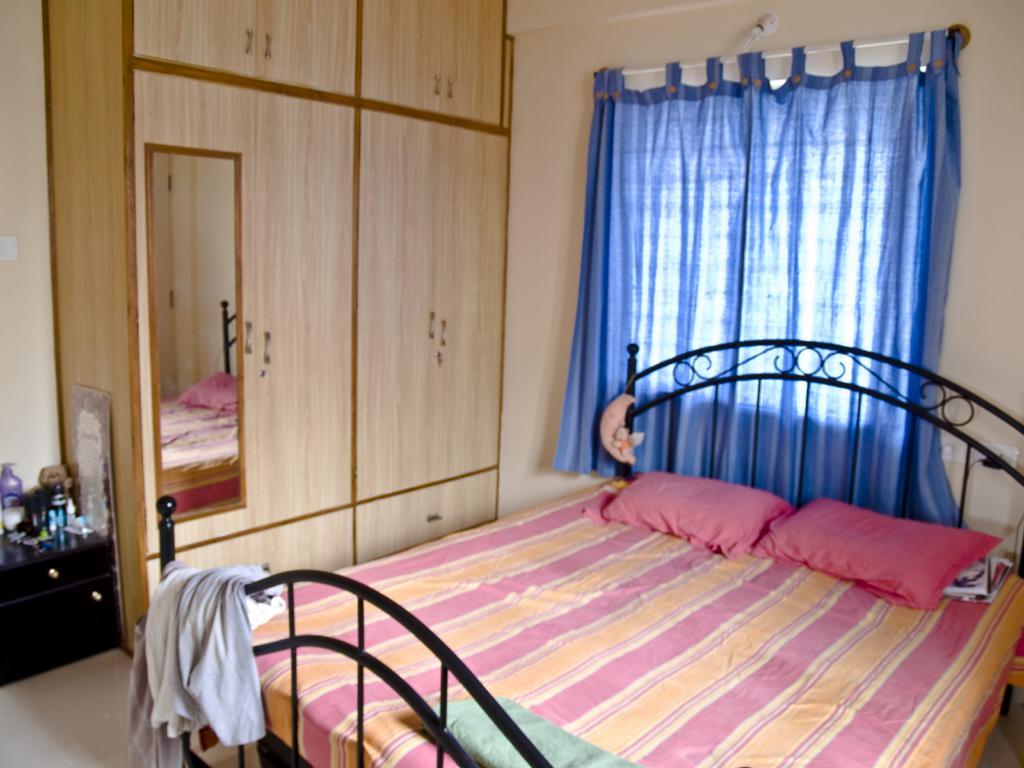Describe this image in one or two sentences. In the image we can see there is a bed and there are pillows kept on the bed. There are curtains on the window and there is a mirror kept on the wooden wardrobe. There are cosmetic items kept on the table and there is a cloth kept on the bed. 